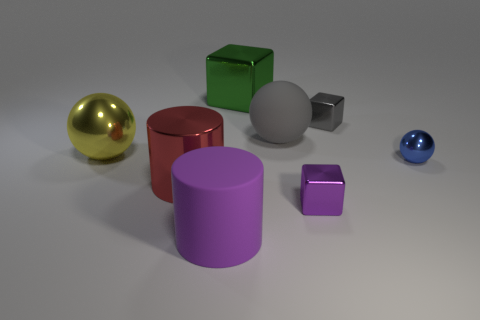Add 2 small yellow balls. How many objects exist? 10 Subtract all spheres. How many objects are left? 5 Add 5 large matte objects. How many large matte objects exist? 7 Subtract 1 gray blocks. How many objects are left? 7 Subtract all big brown rubber spheres. Subtract all purple cubes. How many objects are left? 7 Add 6 metal spheres. How many metal spheres are left? 8 